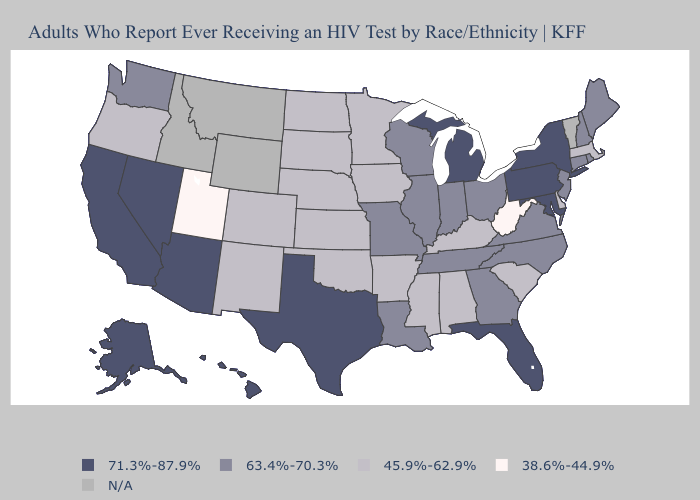What is the lowest value in states that border Arizona?
Write a very short answer. 38.6%-44.9%. Does Colorado have the highest value in the USA?
Concise answer only. No. Name the states that have a value in the range 38.6%-44.9%?
Give a very brief answer. Utah, West Virginia. What is the highest value in states that border Wyoming?
Keep it brief. 45.9%-62.9%. What is the value of Illinois?
Answer briefly. 63.4%-70.3%. Name the states that have a value in the range 63.4%-70.3%?
Give a very brief answer. Connecticut, Georgia, Illinois, Indiana, Louisiana, Maine, Missouri, New Hampshire, New Jersey, North Carolina, Ohio, Rhode Island, Tennessee, Virginia, Washington, Wisconsin. Which states have the highest value in the USA?
Answer briefly. Alaska, Arizona, California, Florida, Hawaii, Maryland, Michigan, Nevada, New York, Pennsylvania, Texas. What is the highest value in the Northeast ?
Short answer required. 71.3%-87.9%. Which states have the lowest value in the Northeast?
Be succinct. Massachusetts. Among the states that border Oregon , which have the highest value?
Write a very short answer. California, Nevada. What is the value of Maine?
Give a very brief answer. 63.4%-70.3%. What is the value of Kansas?
Quick response, please. 45.9%-62.9%. Name the states that have a value in the range 45.9%-62.9%?
Write a very short answer. Alabama, Arkansas, Colorado, Delaware, Iowa, Kansas, Kentucky, Massachusetts, Minnesota, Mississippi, Nebraska, New Mexico, North Dakota, Oklahoma, Oregon, South Carolina, South Dakota. 